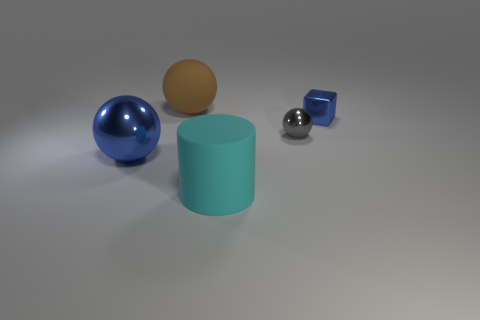Subtract all big balls. How many balls are left? 1 Add 2 big brown blocks. How many objects exist? 7 Subtract all balls. How many objects are left? 2 Subtract all big red shiny cylinders. Subtract all blue spheres. How many objects are left? 4 Add 4 large brown rubber things. How many large brown rubber things are left? 5 Add 4 large red metallic objects. How many large red metallic objects exist? 4 Subtract 0 purple spheres. How many objects are left? 5 